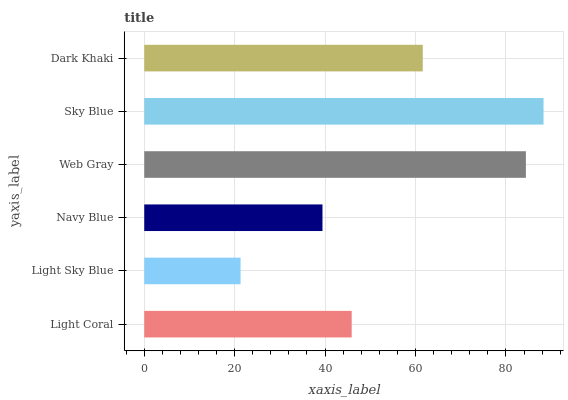Is Light Sky Blue the minimum?
Answer yes or no. Yes. Is Sky Blue the maximum?
Answer yes or no. Yes. Is Navy Blue the minimum?
Answer yes or no. No. Is Navy Blue the maximum?
Answer yes or no. No. Is Navy Blue greater than Light Sky Blue?
Answer yes or no. Yes. Is Light Sky Blue less than Navy Blue?
Answer yes or no. Yes. Is Light Sky Blue greater than Navy Blue?
Answer yes or no. No. Is Navy Blue less than Light Sky Blue?
Answer yes or no. No. Is Dark Khaki the high median?
Answer yes or no. Yes. Is Light Coral the low median?
Answer yes or no. Yes. Is Sky Blue the high median?
Answer yes or no. No. Is Sky Blue the low median?
Answer yes or no. No. 